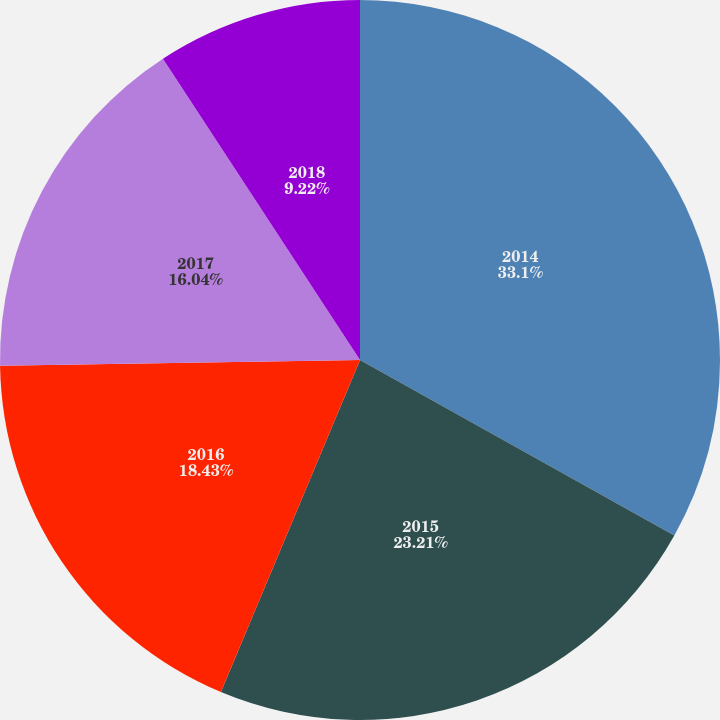Convert chart. <chart><loc_0><loc_0><loc_500><loc_500><pie_chart><fcel>2014<fcel>2015<fcel>2016<fcel>2017<fcel>2018<nl><fcel>33.11%<fcel>23.21%<fcel>18.43%<fcel>16.04%<fcel>9.22%<nl></chart> 